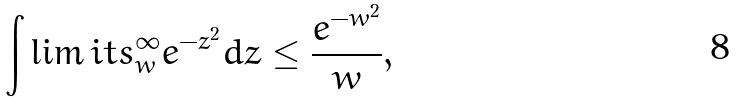<formula> <loc_0><loc_0><loc_500><loc_500>\int \lim i t s _ { w } ^ { \infty } e ^ { - z ^ { 2 } } d z \leq \frac { e ^ { - w ^ { 2 } } } { w } ,</formula> 